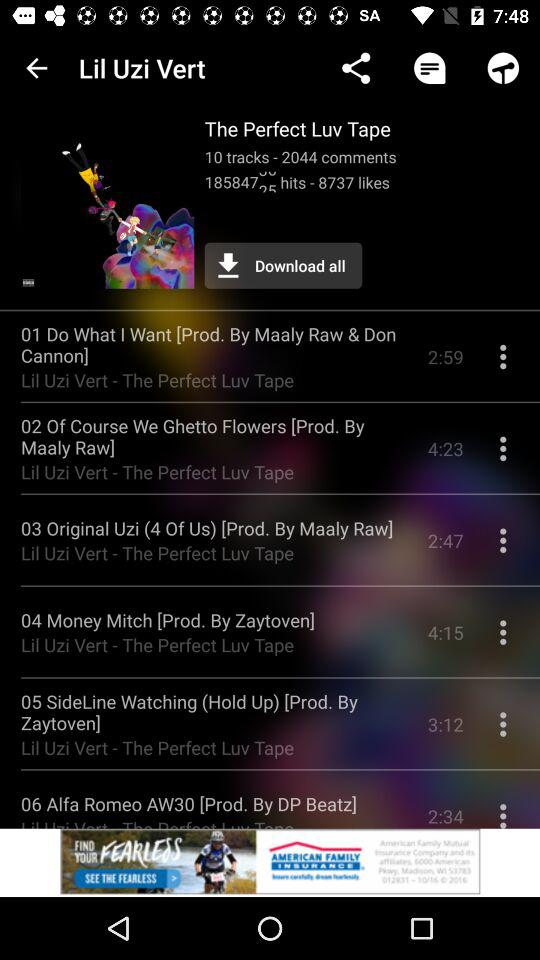How many tracks are there on the album?
Answer the question using a single word or phrase. 10 